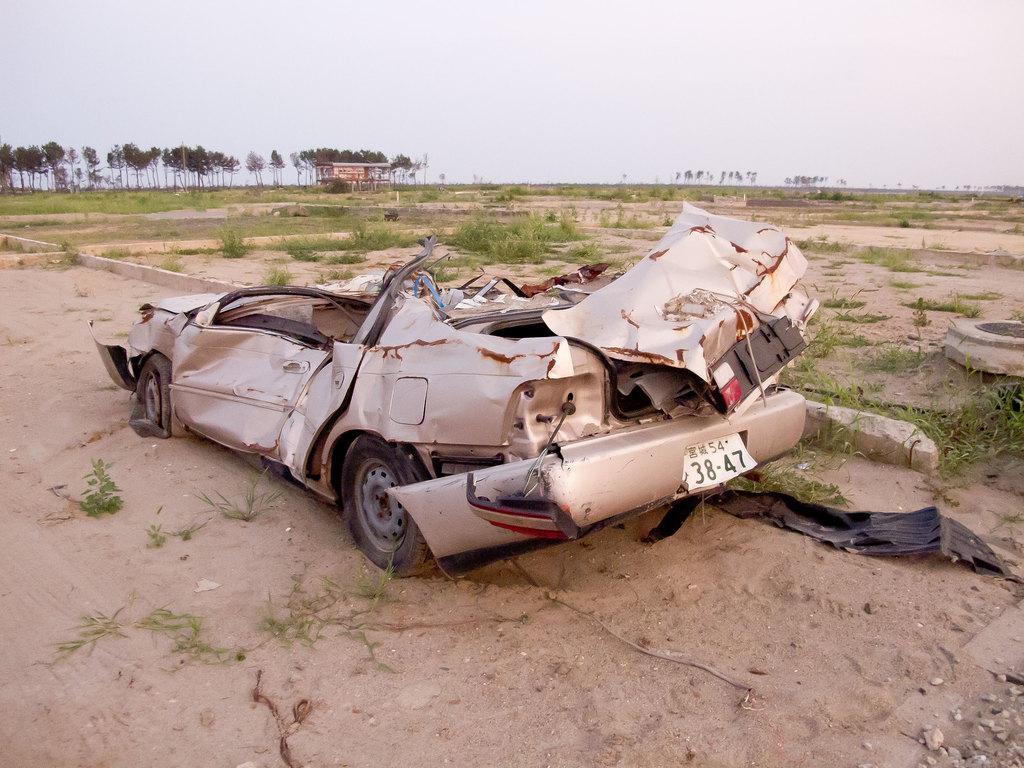Describe this image in one or two sentences. In the center of the image, we can see a damaged vehicle and in the background, there are plant and we can see a shed and trees. At the bottom, there is ground. 